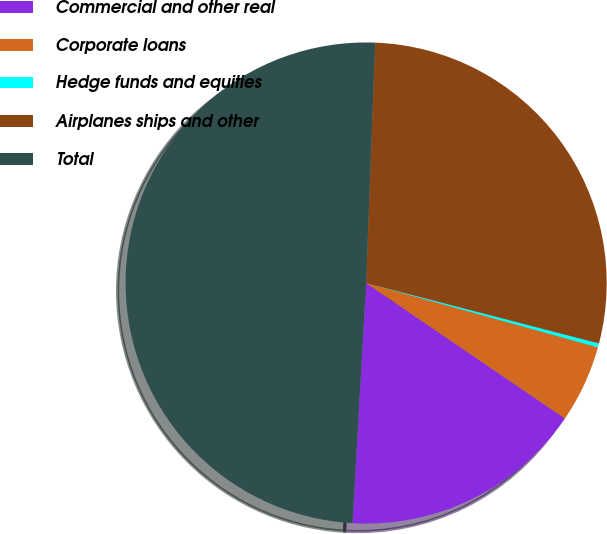<chart> <loc_0><loc_0><loc_500><loc_500><pie_chart><fcel>Commercial and other real<fcel>Corporate loans<fcel>Hedge funds and equities<fcel>Airplanes ships and other<fcel>Total<nl><fcel>16.38%<fcel>5.21%<fcel>0.27%<fcel>28.44%<fcel>49.7%<nl></chart> 